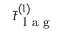Convert formula to latex. <formula><loc_0><loc_0><loc_500><loc_500>\bar { t } _ { l a g } ^ { ( 1 ) }</formula> 